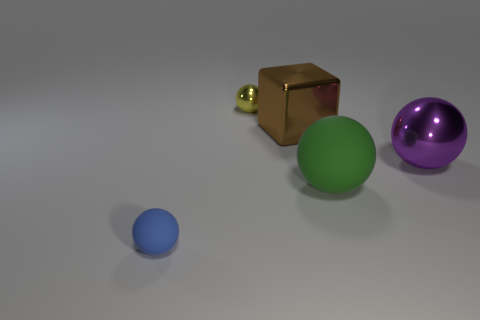Subtract all yellow spheres. Subtract all gray cubes. How many spheres are left? 3 Add 1 cyan cylinders. How many objects exist? 6 Subtract all balls. How many objects are left? 1 Subtract all gray shiny spheres. Subtract all blue matte spheres. How many objects are left? 4 Add 4 big shiny things. How many big shiny things are left? 6 Add 1 metallic spheres. How many metallic spheres exist? 3 Subtract 1 purple balls. How many objects are left? 4 